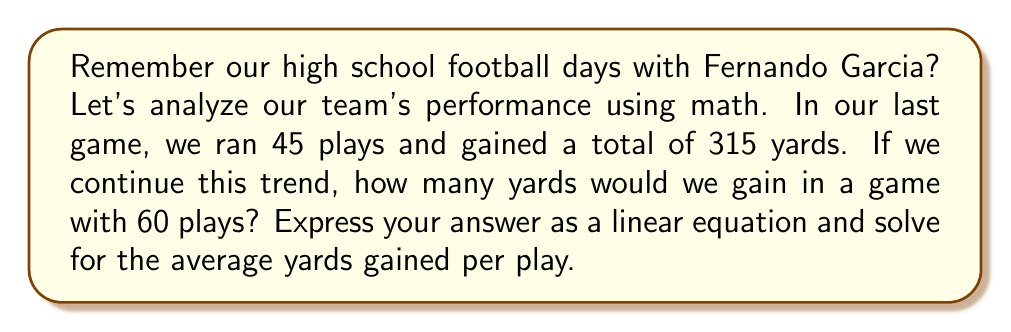Teach me how to tackle this problem. Let's approach this step-by-step:

1) First, we need to set up our linear equation. Let's define our variables:
   $x$ = number of plays
   $y$ = total yards gained

2) We know two points on this line:
   (45, 315) - from the given information
   (60, y) - what we're trying to find

3) The slope-intercept form of a linear equation is $y = mx + b$, where $m$ is the slope and $b$ is the y-intercept.

4) To find the slope $m$, we can use the average yards per play:
   $m = \frac{315 \text{ yards}}{45 \text{ plays}} = 7 \text{ yards/play}$

5) Now our equation looks like: $y = 7x + b$

6) To find $b$, we can plug in the known point (45, 315):
   $315 = 7(45) + b$
   $315 = 315 + b$
   $b = 0$

7) Our final equation is: $y = 7x$

8) To find the yards for 60 plays, we substitute $x = 60$:
   $y = 7(60) = 420$ yards

9) The average yards per play is the slope of this line, which we calculated as 7 yards/play.
Answer: $y = 7x$; 7 yards/play 